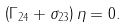<formula> <loc_0><loc_0><loc_500><loc_500>\left ( \Gamma _ { 2 4 } + \sigma _ { 2 3 } \right ) \eta = 0 .</formula> 